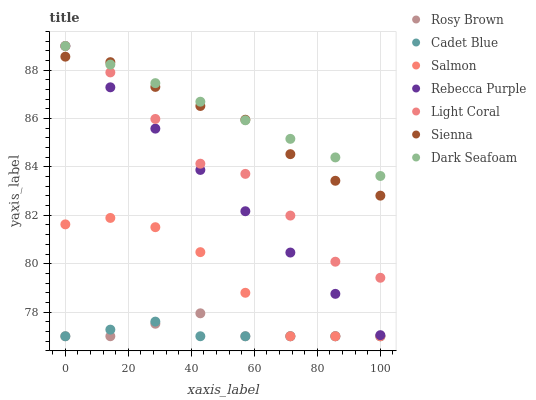Does Cadet Blue have the minimum area under the curve?
Answer yes or no. Yes. Does Dark Seafoam have the maximum area under the curve?
Answer yes or no. Yes. Does Rosy Brown have the minimum area under the curve?
Answer yes or no. No. Does Rosy Brown have the maximum area under the curve?
Answer yes or no. No. Is Dark Seafoam the smoothest?
Answer yes or no. Yes. Is Light Coral the roughest?
Answer yes or no. Yes. Is Cadet Blue the smoothest?
Answer yes or no. No. Is Cadet Blue the roughest?
Answer yes or no. No. Does Cadet Blue have the lowest value?
Answer yes or no. Yes. Does Light Coral have the lowest value?
Answer yes or no. No. Does Rebecca Purple have the highest value?
Answer yes or no. Yes. Does Rosy Brown have the highest value?
Answer yes or no. No. Is Cadet Blue less than Light Coral?
Answer yes or no. Yes. Is Rebecca Purple greater than Cadet Blue?
Answer yes or no. Yes. Does Rebecca Purple intersect Sienna?
Answer yes or no. Yes. Is Rebecca Purple less than Sienna?
Answer yes or no. No. Is Rebecca Purple greater than Sienna?
Answer yes or no. No. Does Cadet Blue intersect Light Coral?
Answer yes or no. No. 